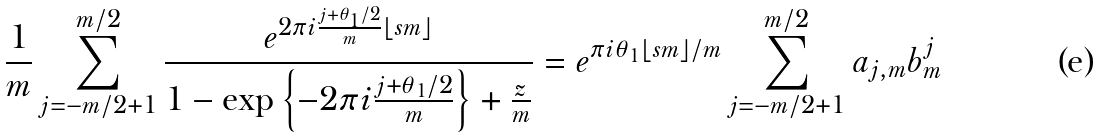Convert formula to latex. <formula><loc_0><loc_0><loc_500><loc_500>\frac { 1 } { m } \sum _ { j = - m / 2 + 1 } ^ { m / 2 } \frac { e ^ { 2 \pi i \frac { j + \theta _ { 1 } / 2 } { m } \lfloor s m \rfloor } } { 1 - \exp \left \{ - 2 \pi i \frac { j + \theta _ { 1 } / 2 } { m } \right \} + \frac { z } { m } } = e ^ { \pi i \theta _ { 1 } \lfloor s m \rfloor / m } \sum _ { j = - m / 2 + 1 } ^ { m / 2 } a _ { j , m } b _ { m } ^ { j }</formula> 